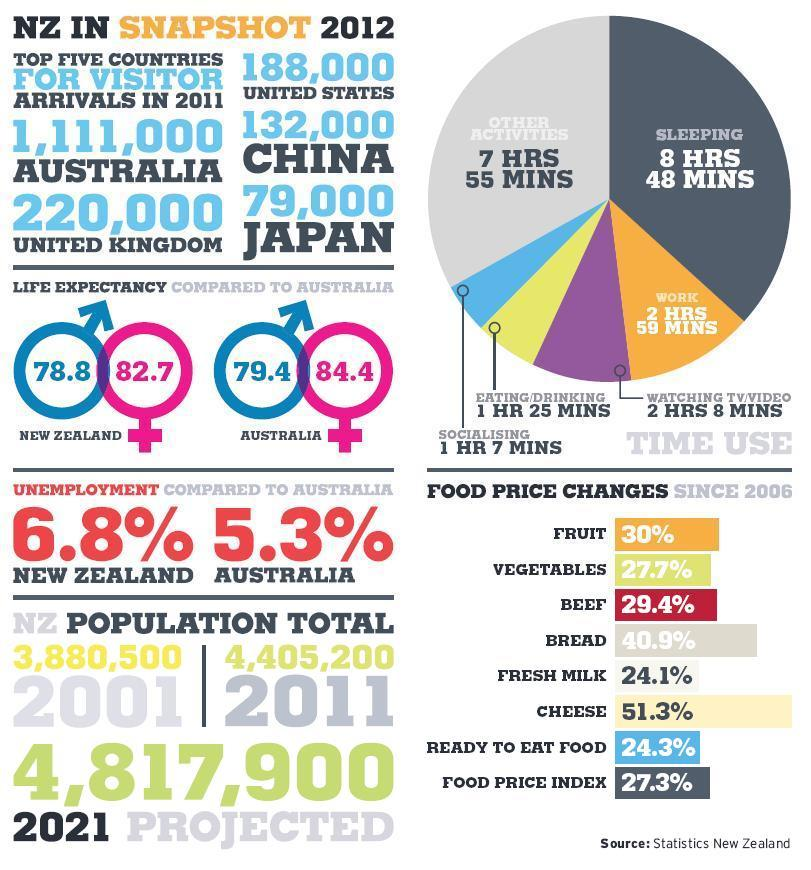Give some essential details in this illustration. The activity that has the highest share is other activities, specifically sleeping. The combined change in the price of ready-to-eat food and the food price index was 51.6%. The life expectancy of females in New Zealand is 82.7 years. The life expectancy for males in Australia is 79.4 years, according to recent data. The price change of fruit and vegetables, taken together, was 57.7%. 